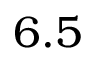Convert formula to latex. <formula><loc_0><loc_0><loc_500><loc_500>6 . 5</formula> 